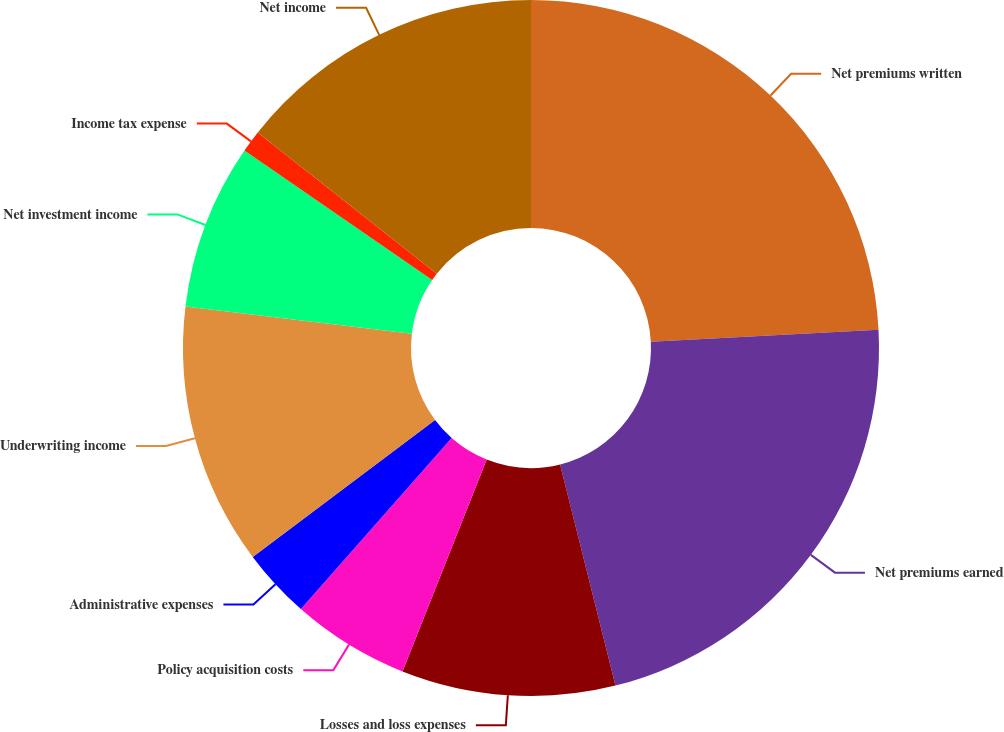<chart> <loc_0><loc_0><loc_500><loc_500><pie_chart><fcel>Net premiums written<fcel>Net premiums earned<fcel>Losses and loss expenses<fcel>Policy acquisition costs<fcel>Administrative expenses<fcel>Underwriting income<fcel>Net investment income<fcel>Income tax expense<fcel>Net income<nl><fcel>24.16%<fcel>21.94%<fcel>9.92%<fcel>5.48%<fcel>3.25%<fcel>12.15%<fcel>7.7%<fcel>1.03%<fcel>14.37%<nl></chart> 